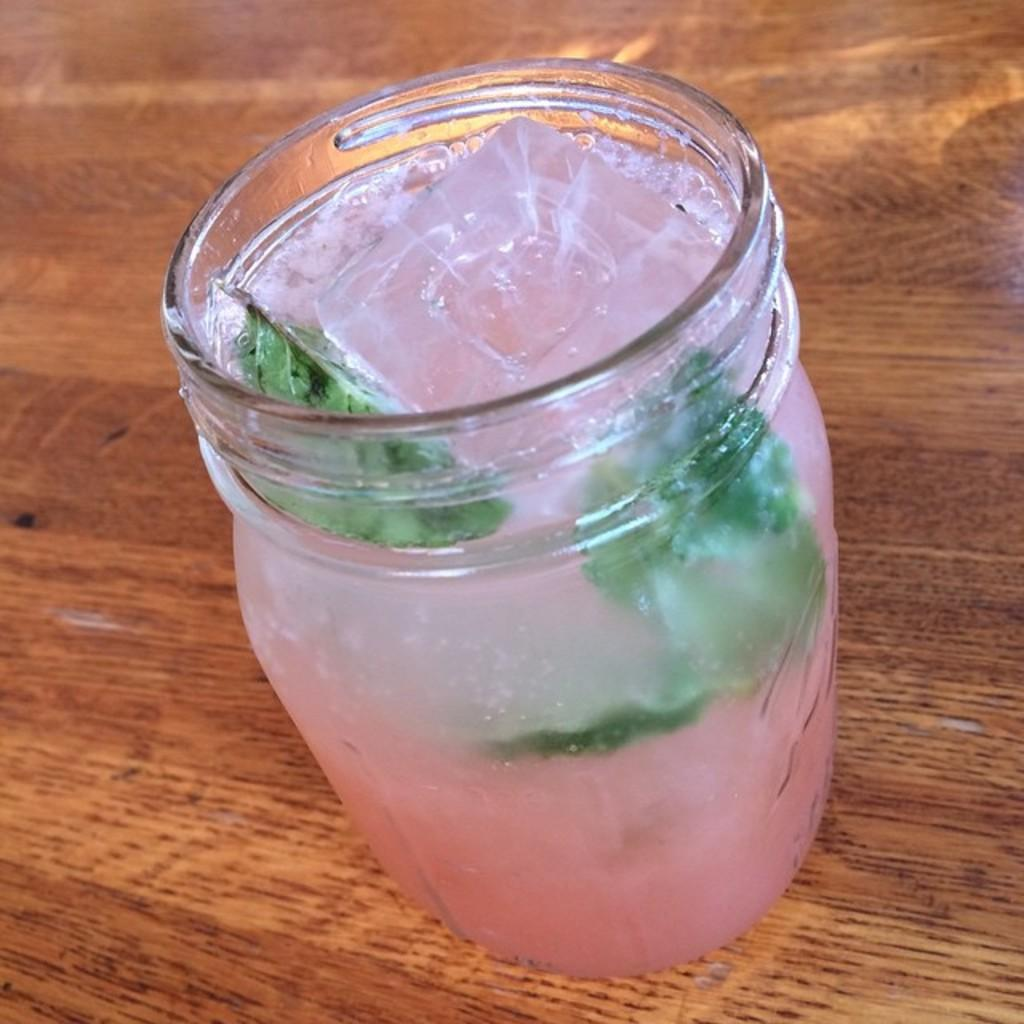What is in the bottle that is visible in the image? The bottle contains ice cubes, leaves, and pink-colored juice. Where is the bottle placed in the image? The bottle is placed on a wooden table. What is the color of the background in the image? The background of the image is brown. What type of income does the carpenter earn in the image? There is no carpenter or mention of income in the image; it features a bottle with ice cubes, leaves, and pink-colored juice on a wooden table with a brown background. 